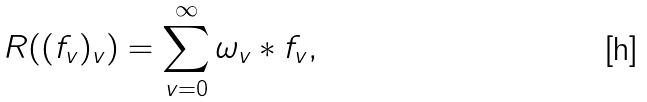Convert formula to latex. <formula><loc_0><loc_0><loc_500><loc_500>R ( ( f _ { v } ) _ { v } ) = \sum _ { v = 0 } ^ { \infty } \omega _ { v } \ast f _ { v } ,</formula> 